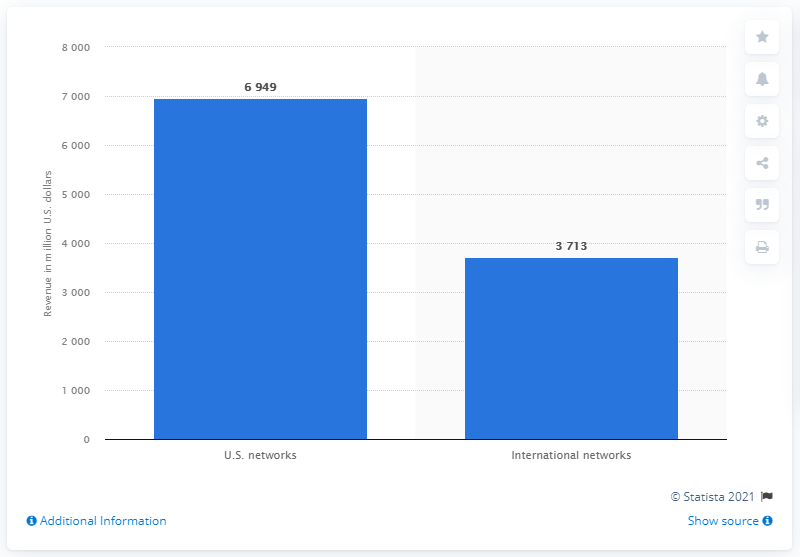Highlight a few significant elements in this photo. In 2020, Discovery Communications generated approximately $69,490 in revenue in the United States. Discovery's international networks reported a significant increase in advertising revenue between 2019 and 2020, with a specific increase of 3,713%. In 2020, Discovery's international networks generated a total revenue of $3,713. 